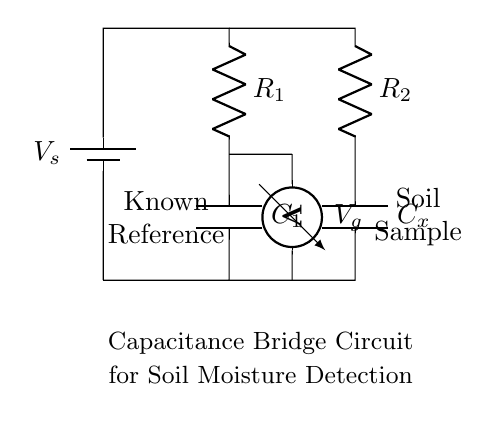What is the main purpose of this circuit? The primary function of this circuit is to measure the moisture content in plant soil by comparing the capacitance of a known reference with that of a soil sample.
Answer: moisture detection What components are present in the circuit? The circuit consists of a battery, two resistors, two capacitors, and a voltmeter. These components are used to create the capacitance bridge necessary for measurement.
Answer: battery, resistors, capacitors, voltmeter What does the voltmeter measure in this circuit? The voltmeter measures the potential difference across the bridge, specifically between the junction of the two resistors and capacitors, which reflects the balance condition of the circuit.
Answer: voltage difference What role does the reference component play? The reference component, represented by capacitor C1 and resistor R1, provides a known capacitance value that is used to compare against the unknown capacitance of the soil sample represented by Cx and R2.
Answer: comparison How does the soil sample affect the circuit? The moisture level in the soil affects the dielectric constant of the soil, which in turn alters the capacitance of Cx, changing the balance of the bridge and thus influencing the measured voltage.
Answer: changes capacitance What type of circuit configuration is used here? This is a capacitance bridge configuration, specifically designed to detect variations in capacitance caused by moisture levels in soil.
Answer: capacitance bridge What happens when the circuit is balanced? When the circuit is balanced, the voltage across the voltmeter reads zero, indicating that the capacitances of the known reference and the soil sample are equal, thus confirming the moisture level.
Answer: zero voltage 